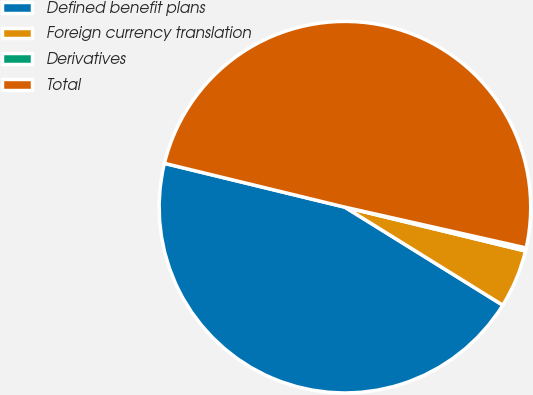<chart> <loc_0><loc_0><loc_500><loc_500><pie_chart><fcel>Defined benefit plans<fcel>Foreign currency translation<fcel>Derivatives<fcel>Total<nl><fcel>44.95%<fcel>5.05%<fcel>0.27%<fcel>49.73%<nl></chart> 